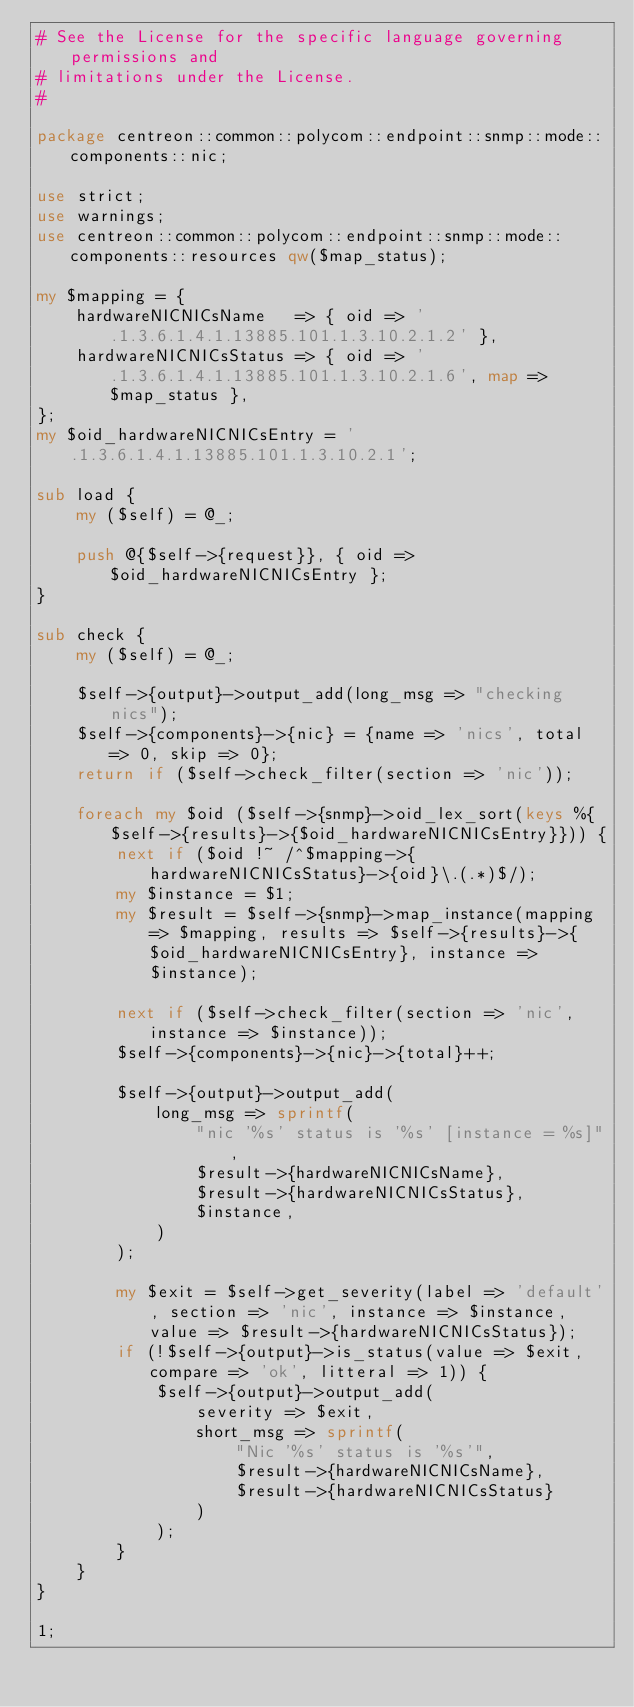<code> <loc_0><loc_0><loc_500><loc_500><_Perl_># See the License for the specific language governing permissions and
# limitations under the License.
#

package centreon::common::polycom::endpoint::snmp::mode::components::nic;

use strict;
use warnings;
use centreon::common::polycom::endpoint::snmp::mode::components::resources qw($map_status);

my $mapping = {
    hardwareNICNICsName   => { oid => '.1.3.6.1.4.1.13885.101.1.3.10.2.1.2' },
    hardwareNICNICsStatus => { oid => '.1.3.6.1.4.1.13885.101.1.3.10.2.1.6', map => $map_status },
};
my $oid_hardwareNICNICsEntry = '.1.3.6.1.4.1.13885.101.1.3.10.2.1';

sub load {
    my ($self) = @_;
    
    push @{$self->{request}}, { oid => $oid_hardwareNICNICsEntry };
}

sub check {
    my ($self) = @_;

    $self->{output}->output_add(long_msg => "checking nics");
    $self->{components}->{nic} = {name => 'nics', total => 0, skip => 0};
    return if ($self->check_filter(section => 'nic'));

    foreach my $oid ($self->{snmp}->oid_lex_sort(keys %{$self->{results}->{$oid_hardwareNICNICsEntry}})) {
        next if ($oid !~ /^$mapping->{hardwareNICNICsStatus}->{oid}\.(.*)$/);
        my $instance = $1;
        my $result = $self->{snmp}->map_instance(mapping => $mapping, results => $self->{results}->{$oid_hardwareNICNICsEntry}, instance => $instance);
        
        next if ($self->check_filter(section => 'nic', instance => $instance));
        $self->{components}->{nic}->{total}++;

        $self->{output}->output_add(
            long_msg => sprintf(
                "nic '%s' status is '%s' [instance = %s]",
                $result->{hardwareNICNICsName},
                $result->{hardwareNICNICsStatus},
                $instance, 
            )
        );

        my $exit = $self->get_severity(label => 'default', section => 'nic', instance => $instance, value => $result->{hardwareNICNICsStatus});
        if (!$self->{output}->is_status(value => $exit, compare => 'ok', litteral => 1)) {
            $self->{output}->output_add(
                severity => $exit,
                short_msg => sprintf(
                    "Nic '%s' status is '%s'",
                    $result->{hardwareNICNICsName},
                    $result->{hardwareNICNICsStatus}
                )
            );
        }
    }
}

1;
</code> 